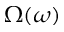<formula> <loc_0><loc_0><loc_500><loc_500>\Omega ( \omega )</formula> 